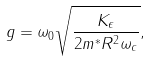<formula> <loc_0><loc_0><loc_500><loc_500>g = \omega _ { 0 } \sqrt { \frac { K _ { \epsilon } } { 2 m ^ { * } R ^ { 2 } \omega _ { c } } } ,</formula> 